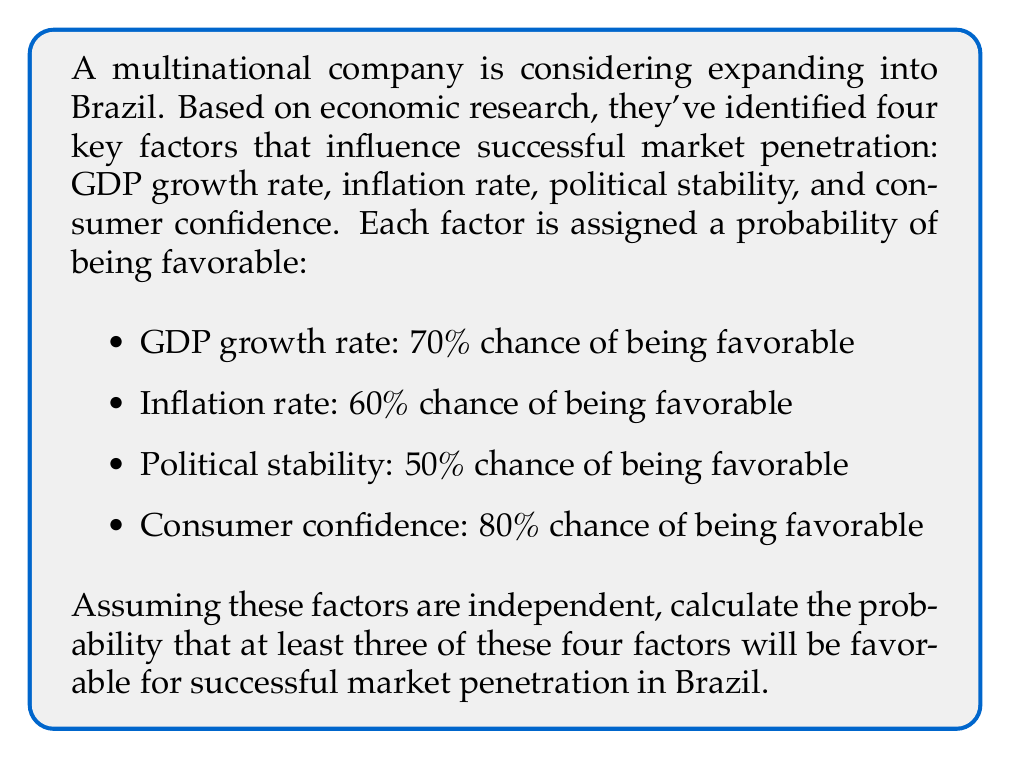Can you answer this question? Let's approach this step-by-step using the complement method:

1) First, let's define our event:
   A = at least three factors are favorable

2) The complement of A is:
   A' = less than three factors are favorable (i.e., 0, 1, or 2 factors are favorable)

3) We know that P(A) + P(A') = 1, so P(A) = 1 - P(A')

4) Let's calculate P(A'):

   P(0 favorable) + P(1 favorable) + P(2 favorable)

5) Using the binomial probability formula:

   $P(X = k) = \binom{n}{k} p^k (1-p)^{n-k}$

   Where n = 4 (total factors), k = number of favorable factors, and p = probability of success for each factor

6) Calculating each term:

   P(0 favorable) = $\binom{4}{0} (0.3 \times 0.4 \times 0.5 \times 0.2) = 0.012$

   P(1 favorable) = $\binom{4}{1} [(0.7 \times 0.4 \times 0.5 \times 0.2) + (0.3 \times 0.6 \times 0.5 \times 0.2) + (0.3 \times 0.4 \times 0.5 \times 0.8) + (0.3 \times 0.4 \times 0.5 \times 0.2)] = 0.0956$

   P(2 favorable) = $\binom{4}{2} [(0.7 \times 0.6 \times 0.5 \times 0.2) + (0.7 \times 0.4 \times 0.5 \times 0.8) + (0.7 \times 0.4 \times 0.5 \times 0.2) + (0.3 \times 0.6 \times 0.5 \times 0.8) + (0.3 \times 0.6 \times 0.5 \times 0.2) + (0.3 \times 0.4 \times 0.5 \times 0.8)] = 0.2856$

7) P(A') = 0.012 + 0.0956 + 0.2856 = 0.3932

8) Therefore, P(A) = 1 - P(A') = 1 - 0.3932 = 0.6068
Answer: 0.6068 or approximately 60.68% 